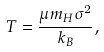<formula> <loc_0><loc_0><loc_500><loc_500>T = \frac { \mu m _ { H } \sigma ^ { 2 } } { k _ { B } } ,</formula> 